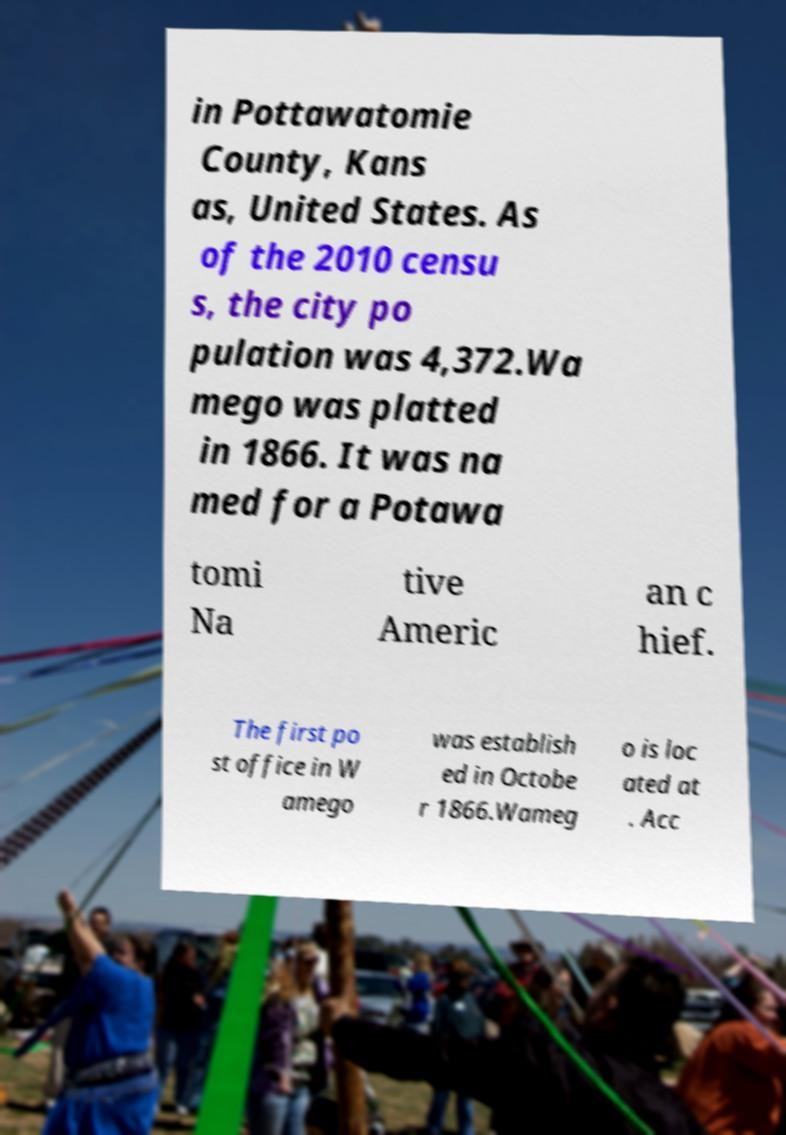What messages or text are displayed in this image? I need them in a readable, typed format. in Pottawatomie County, Kans as, United States. As of the 2010 censu s, the city po pulation was 4,372.Wa mego was platted in 1866. It was na med for a Potawa tomi Na tive Americ an c hief. The first po st office in W amego was establish ed in Octobe r 1866.Wameg o is loc ated at . Acc 